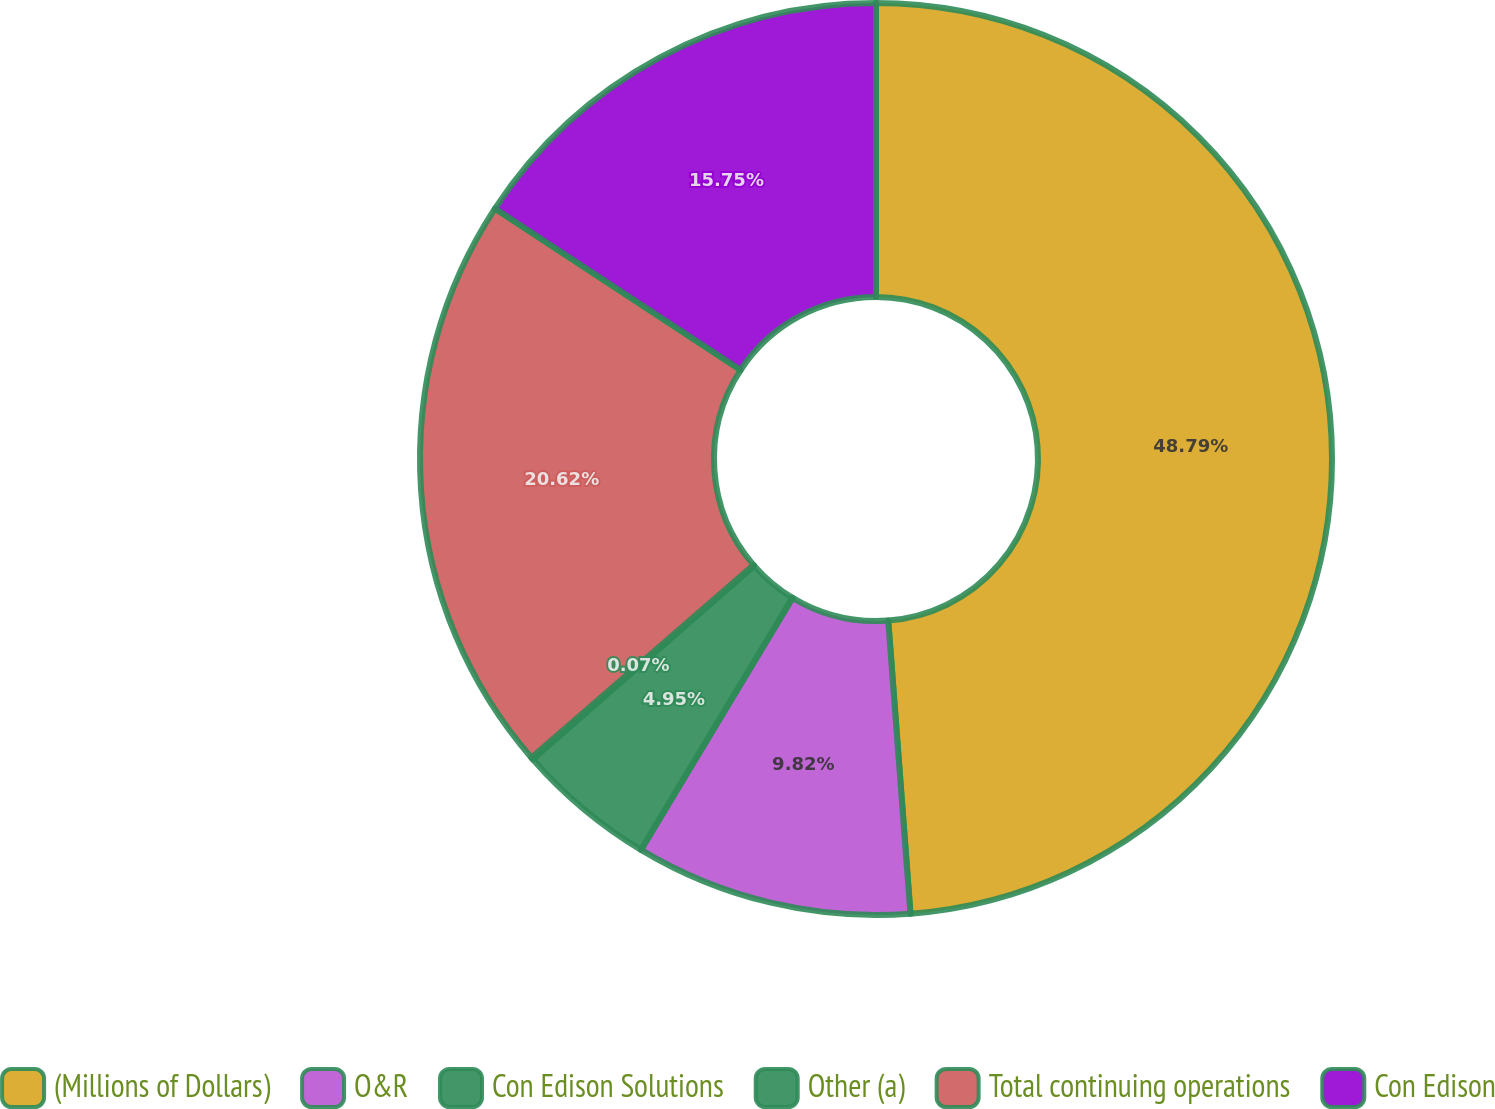Convert chart. <chart><loc_0><loc_0><loc_500><loc_500><pie_chart><fcel>(Millions of Dollars)<fcel>O&R<fcel>Con Edison Solutions<fcel>Other (a)<fcel>Total continuing operations<fcel>Con Edison<nl><fcel>48.8%<fcel>9.82%<fcel>4.95%<fcel>0.07%<fcel>20.62%<fcel>15.75%<nl></chart> 